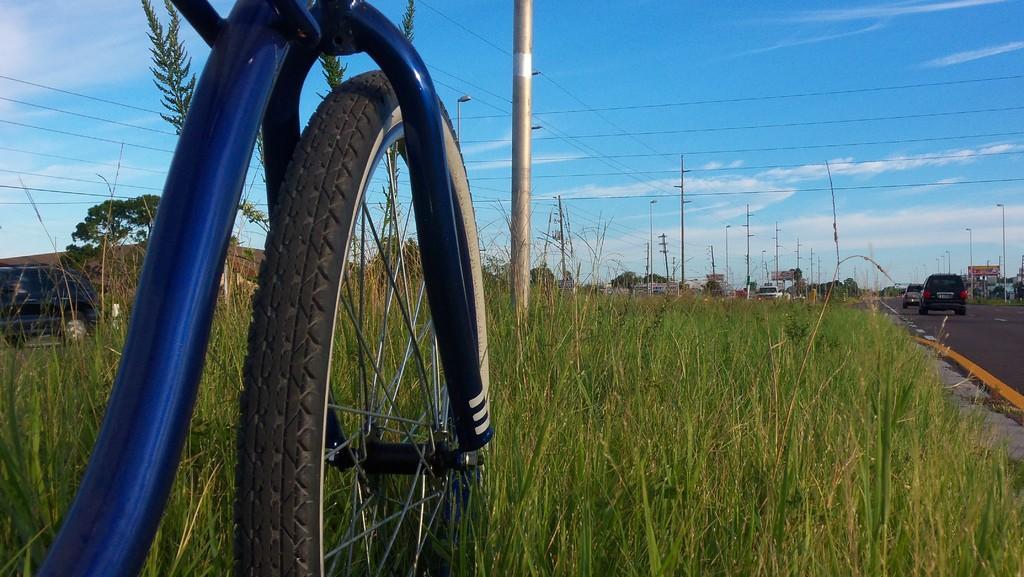Please provide a concise description of this image. This image is taken outdoors. At the top of the image there is the sky with clouds. At the bottom of the image there is a ground with grass on it. On the right side of the image there is a road and a few cars are moving on the road. There is a board with a text on it. There are many poles with street lights. In the middle of the image there is a bicycle parked on the ground. A car is moving on the road. In the middle of the image there is a pole and there are many poles which street lights and wires. A car is moving on the road. In the background there are many trees. 